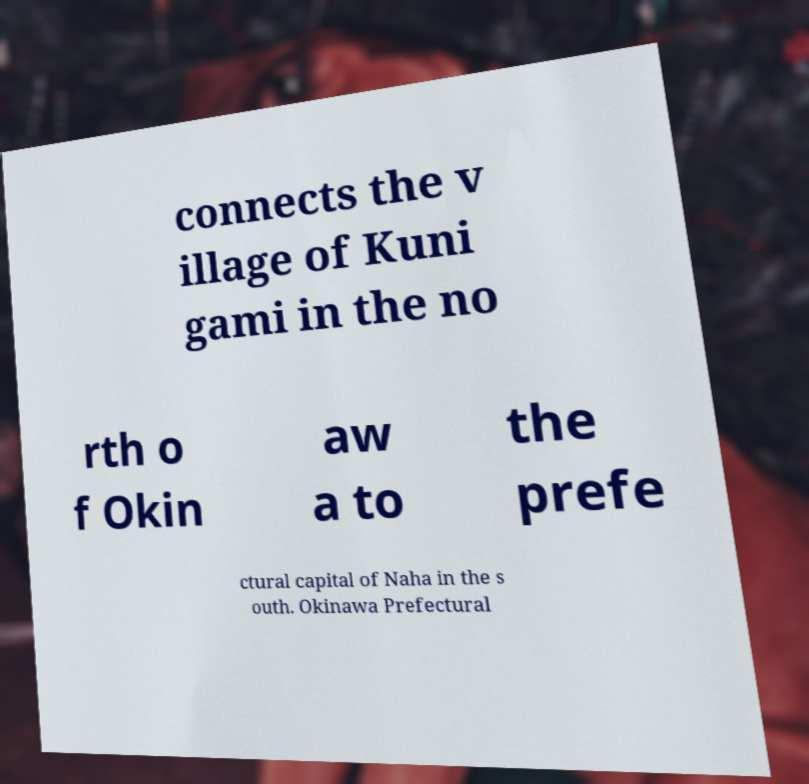For documentation purposes, I need the text within this image transcribed. Could you provide that? connects the v illage of Kuni gami in the no rth o f Okin aw a to the prefe ctural capital of Naha in the s outh. Okinawa Prefectural 